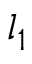Convert formula to latex. <formula><loc_0><loc_0><loc_500><loc_500>l _ { 1 }</formula> 